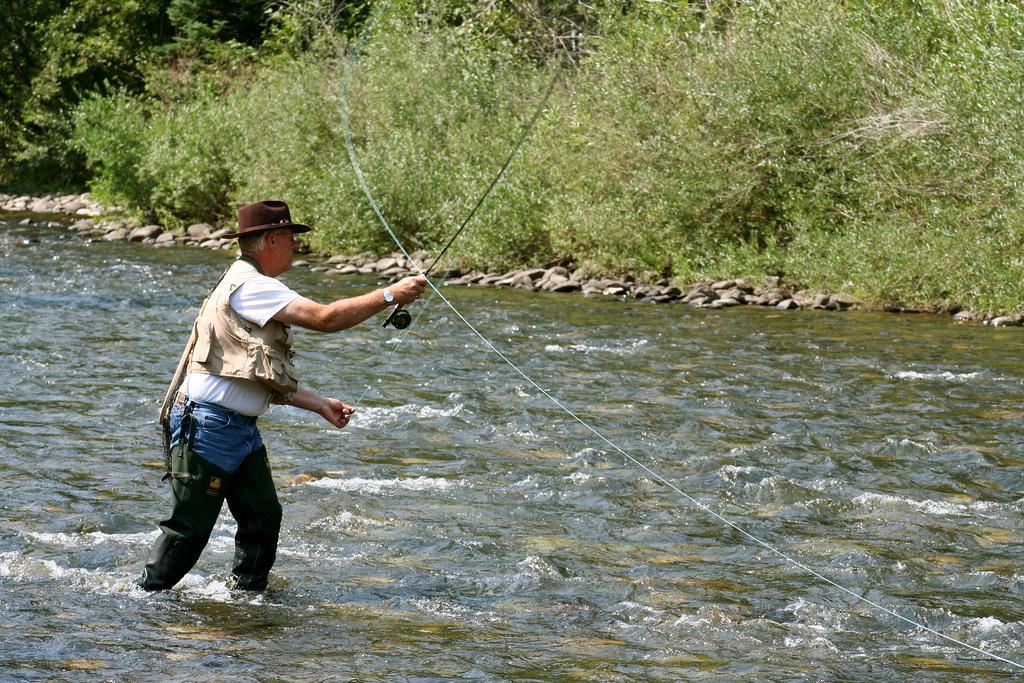What is the person in the image doing? The person is standing in the water and fishing. Where is the person located? The person is in a river. What can be seen in the background of the image? There are plenty of trees beside the river. What type of egg can be seen floating in the river in the image? There is no egg present in the image; the person is fishing, not collecting eggs. 